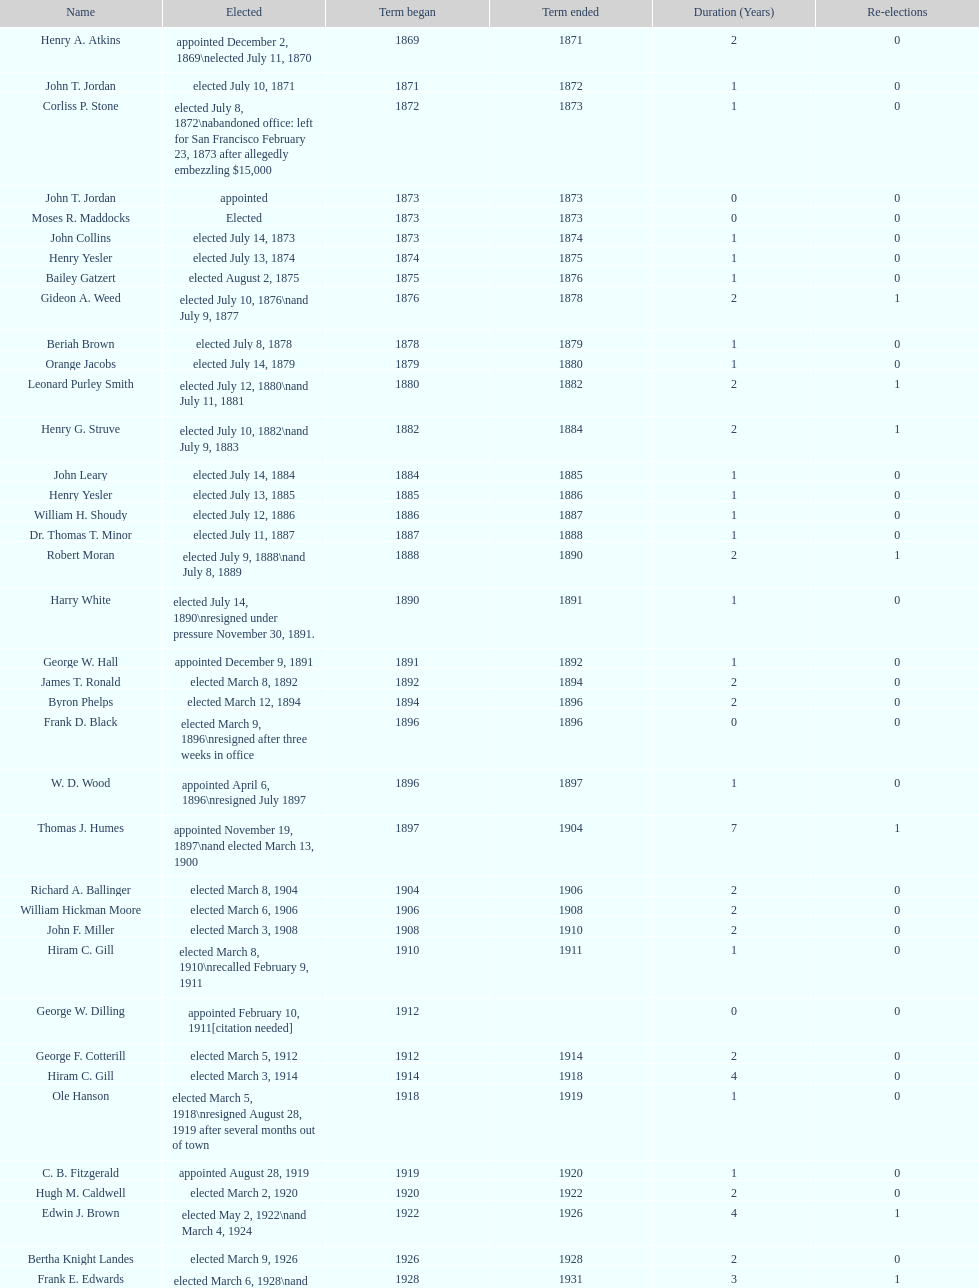Did charles royer hold office longer than paul schell? Yes. 